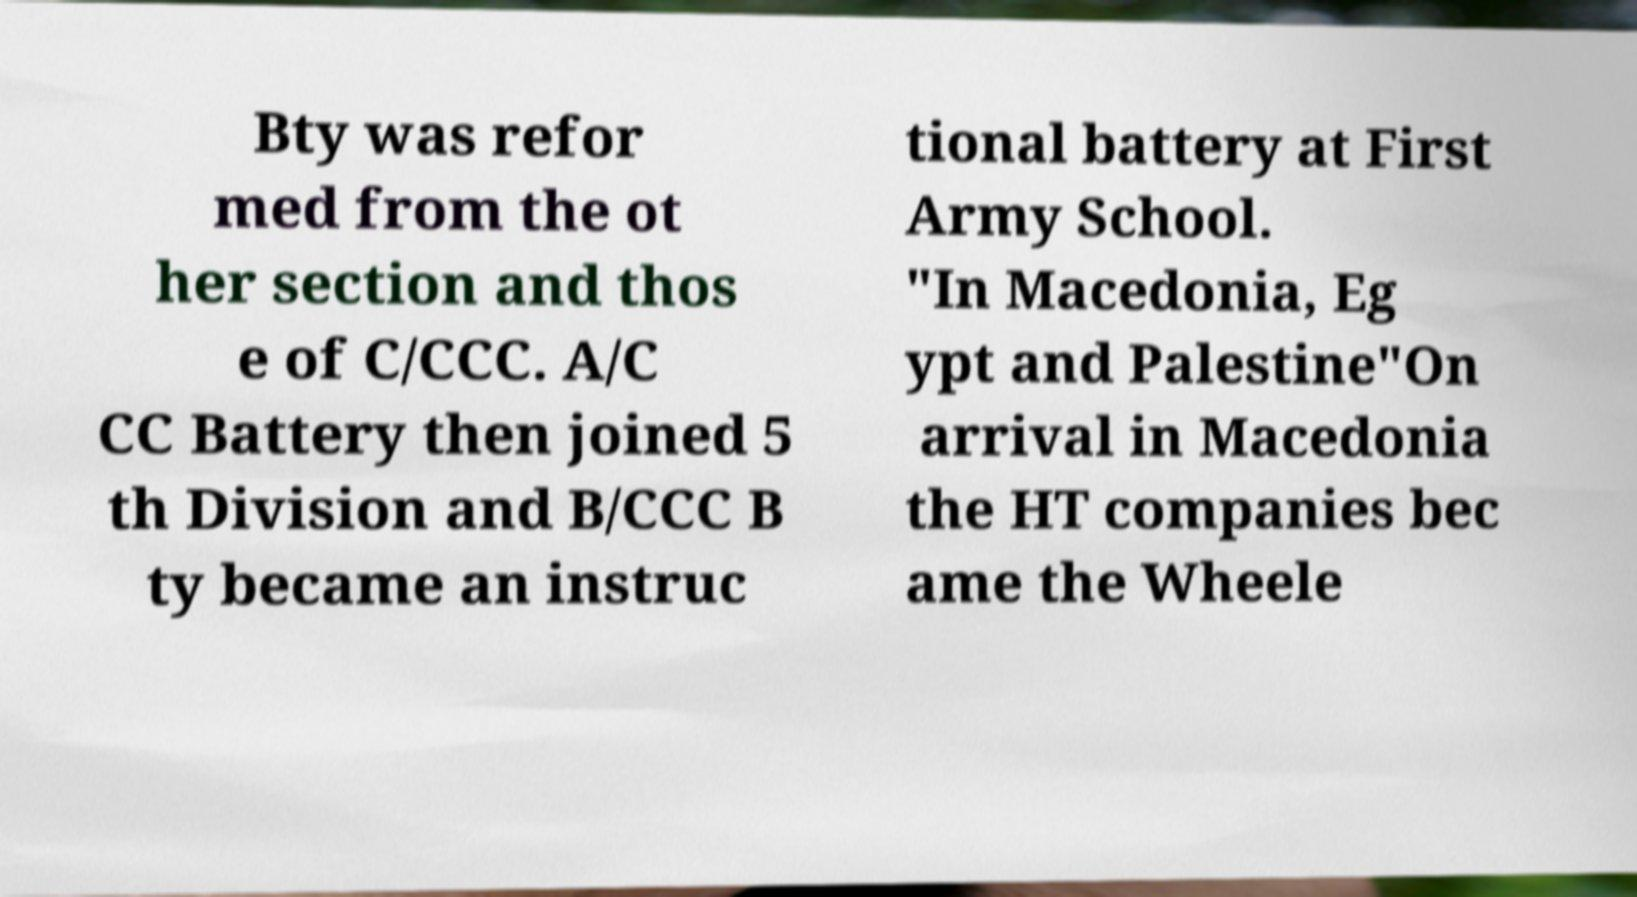For documentation purposes, I need the text within this image transcribed. Could you provide that? Bty was refor med from the ot her section and thos e of C/CCC. A/C CC Battery then joined 5 th Division and B/CCC B ty became an instruc tional battery at First Army School. "In Macedonia, Eg ypt and Palestine"On arrival in Macedonia the HT companies bec ame the Wheele 